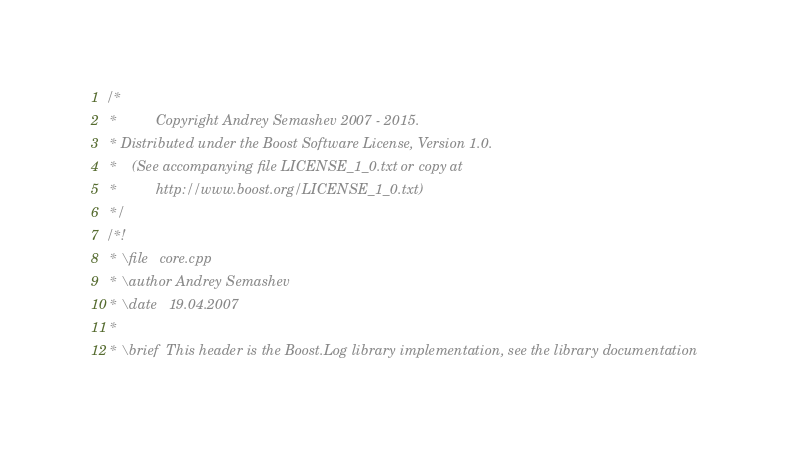Convert code to text. <code><loc_0><loc_0><loc_500><loc_500><_C++_>/*
 *          Copyright Andrey Semashev 2007 - 2015.
 * Distributed under the Boost Software License, Version 1.0.
 *    (See accompanying file LICENSE_1_0.txt or copy at
 *          http://www.boost.org/LICENSE_1_0.txt)
 */
/*!
 * \file   core.cpp
 * \author Andrey Semashev
 * \date   19.04.2007
 *
 * \brief  This header is the Boost.Log library implementation, see the library documentation</code> 